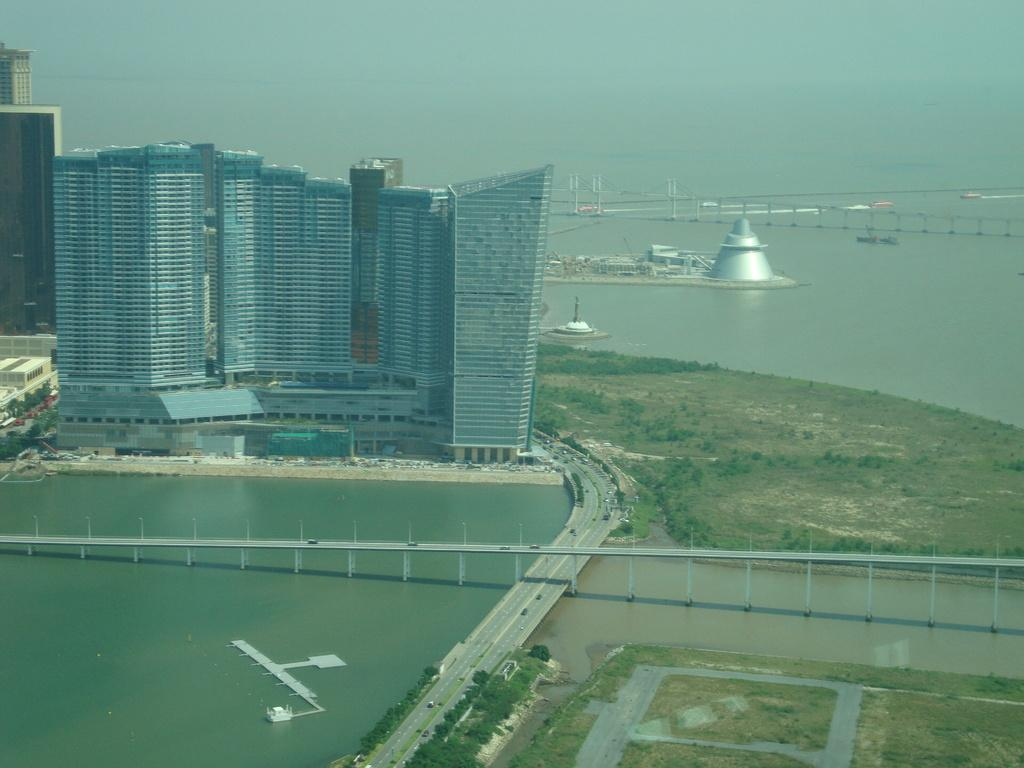What is the main structure in the center of the image? There is a building in the center of the image. What natural element is present in the image? There is water in the image. What type of man-made structure can be seen in the image? There is a bridge in the image. What type of transportation infrastructure is visible in the image? There are roads in the image. What type of vegetation is present in the image? There are trees in the image. What part of the natural environment is visible in the image? The ground is visible in the image. What type of watercraft can be seen in the top right corner of the image? Boats are present in the top right corner of the image. What part of the sky is visible in the image? The sky is visible at the top of the image. What type of nose can be seen on the building in the image? There is no nose present on the building in the image. What type of society is depicted in the image? The image does not depict a society; it shows a building, water, a bridge, roads, trees, the ground, boats, and the sky. 